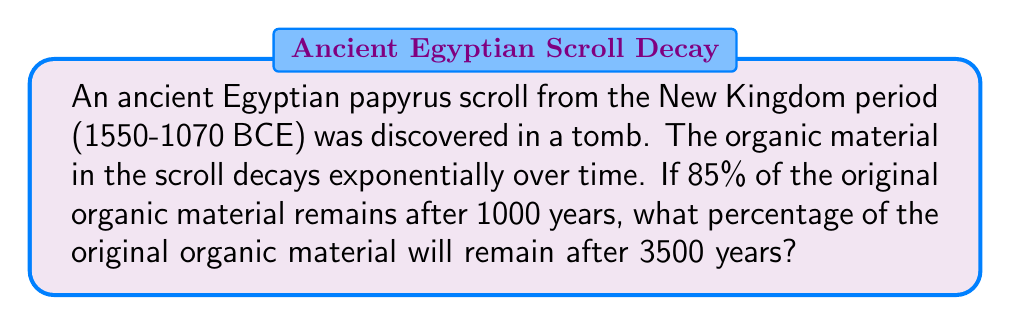Show me your answer to this math problem. Let's approach this step-by-step using exponential decay function:

1) The general form of exponential decay is:
   $A(t) = A_0 \cdot e^{-kt}$
   where $A(t)$ is the amount at time $t$, $A_0$ is the initial amount, $k$ is the decay constant, and $t$ is time.

2) We know that after 1000 years, 85% of the material remains. Let's use this to find $k$:
   $0.85 = e^{-k \cdot 1000}$

3) Taking natural log of both sides:
   $\ln(0.85) = -1000k$

4) Solving for $k$:
   $k = -\frac{\ln(0.85)}{1000} \approx 0.0001625$

5) Now that we have $k$, we can use the original exponential decay formula to find the percentage after 3500 years:
   $A(3500) = 1 \cdot e^{-0.0001625 \cdot 3500}$

6) Calculating this:
   $A(3500) = e^{-0.56875} \approx 0.5662$

7) Converting to a percentage:
   $0.5662 \cdot 100\% \approx 56.62\%$

Thus, after 3500 years, approximately 56.62% of the original organic material will remain.
Answer: 56.62% 